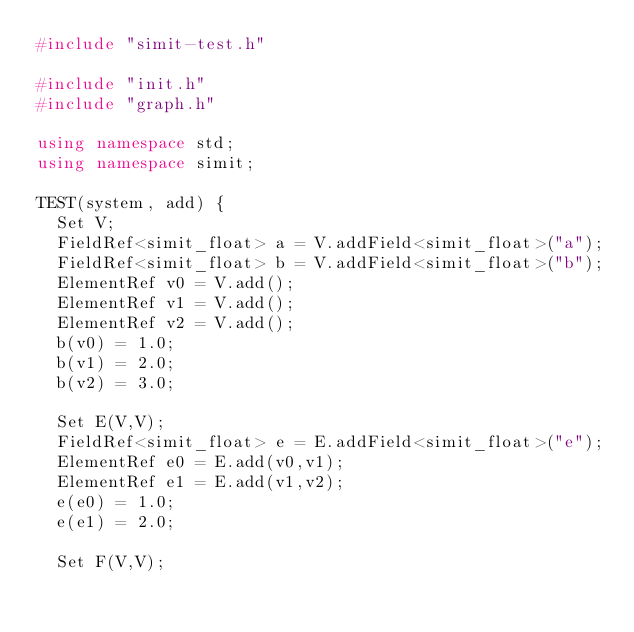<code> <loc_0><loc_0><loc_500><loc_500><_C++_>#include "simit-test.h"

#include "init.h"
#include "graph.h"

using namespace std;
using namespace simit;

TEST(system, add) {
  Set V;
  FieldRef<simit_float> a = V.addField<simit_float>("a");
  FieldRef<simit_float> b = V.addField<simit_float>("b");
  ElementRef v0 = V.add();
  ElementRef v1 = V.add();
  ElementRef v2 = V.add();
  b(v0) = 1.0;
  b(v1) = 2.0;
  b(v2) = 3.0;

  Set E(V,V);
  FieldRef<simit_float> e = E.addField<simit_float>("e");
  ElementRef e0 = E.add(v0,v1);
  ElementRef e1 = E.add(v1,v2);
  e(e0) = 1.0;
  e(e1) = 2.0;

  Set F(V,V);</code> 